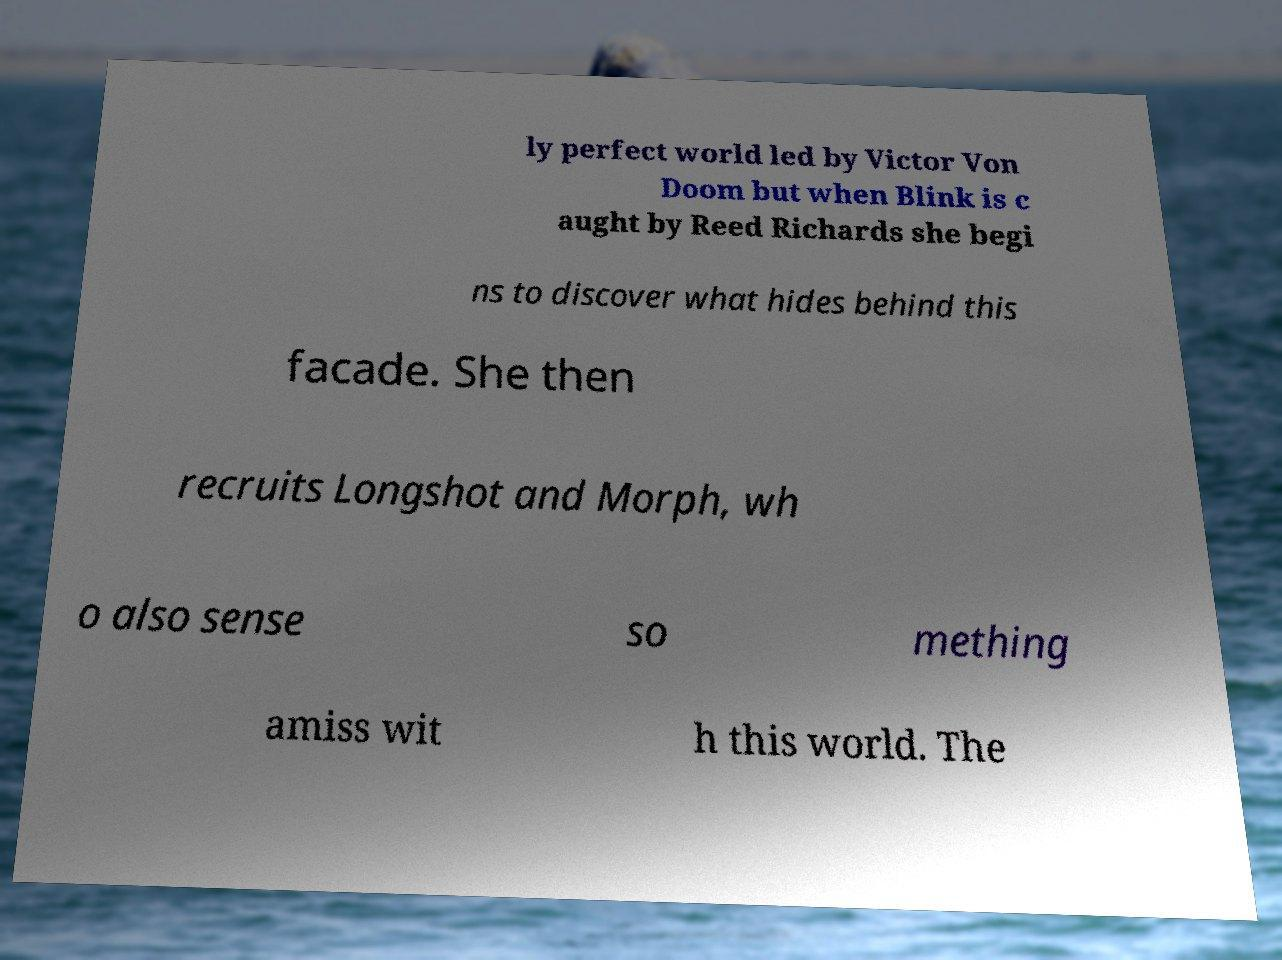Could you assist in decoding the text presented in this image and type it out clearly? ly perfect world led by Victor Von Doom but when Blink is c aught by Reed Richards she begi ns to discover what hides behind this facade. She then recruits Longshot and Morph, wh o also sense so mething amiss wit h this world. The 